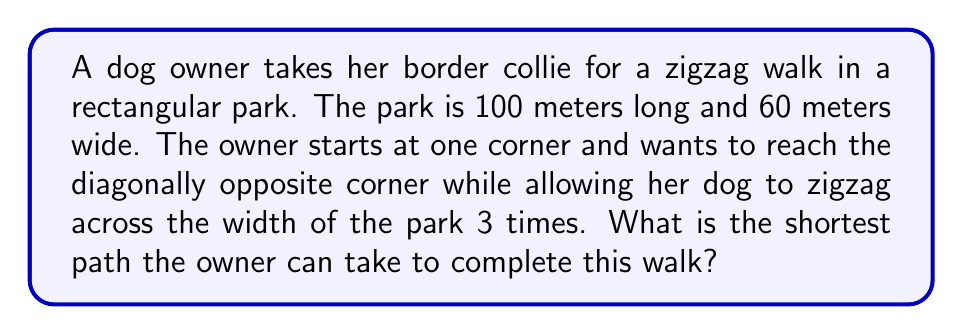Could you help me with this problem? Let's approach this step-by-step:

1) First, we need to visualize the path. The zigzag will look like this:

[asy]
size(200);
draw((0,0)--(100,0)--(100,60)--(0,60)--cycle);
draw((0,0)--(20,60)--(40,0)--(60,60)--(80,0)--(100,60));
label("Start", (0,0), SW);
label("End", (100,60), NE);
[/asy]

2) The path consists of 5 line segments (3 full zigzags across the width).

3) To find the shortest path, we need to determine where to place the turning points along the length of the park.

4) Due to the symmetry of the problem, the optimal solution will have equal spacing between these turning points.

5) Let's call the distance between each turning point $x$. Since there are 5 segments, we have:

   $5x = 100$ meters

6) Solving for $x$:
   
   $x = 20$ meters

7) Now, each segment of the zigzag forms a right triangle. The base of this triangle is 20 meters, and the height is 60 meters (the width of the park).

8) We can find the length of each segment using the Pythagorean theorem:

   $\text{segment length} = \sqrt{20^2 + 60^2} = \sqrt{400 + 3600} = \sqrt{4000} = 20\sqrt{10}$ meters

9) Since there are 5 such segments, the total path length is:

   $\text{total length} = 5 * 20\sqrt{10} = 100\sqrt{10}$ meters

Therefore, the shortest path for this zigzag walk is $100\sqrt{10}$ meters.
Answer: $100\sqrt{10}$ meters 